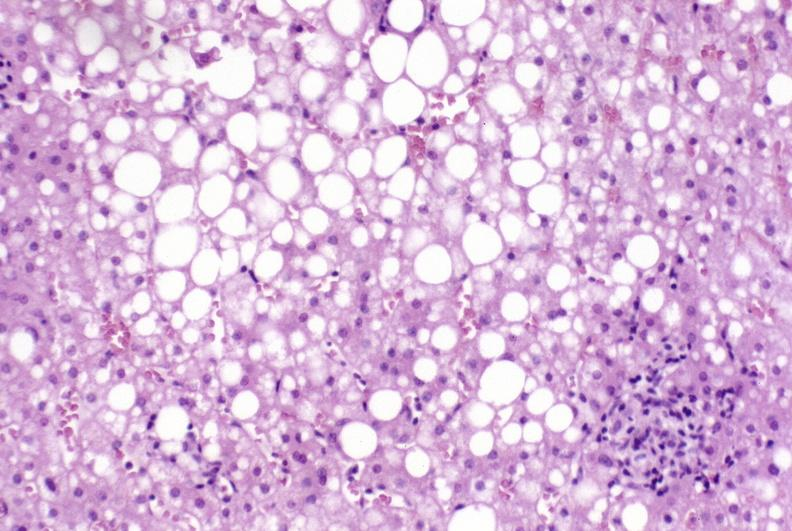s metastatic neuroblastoma present?
Answer the question using a single word or phrase. No 